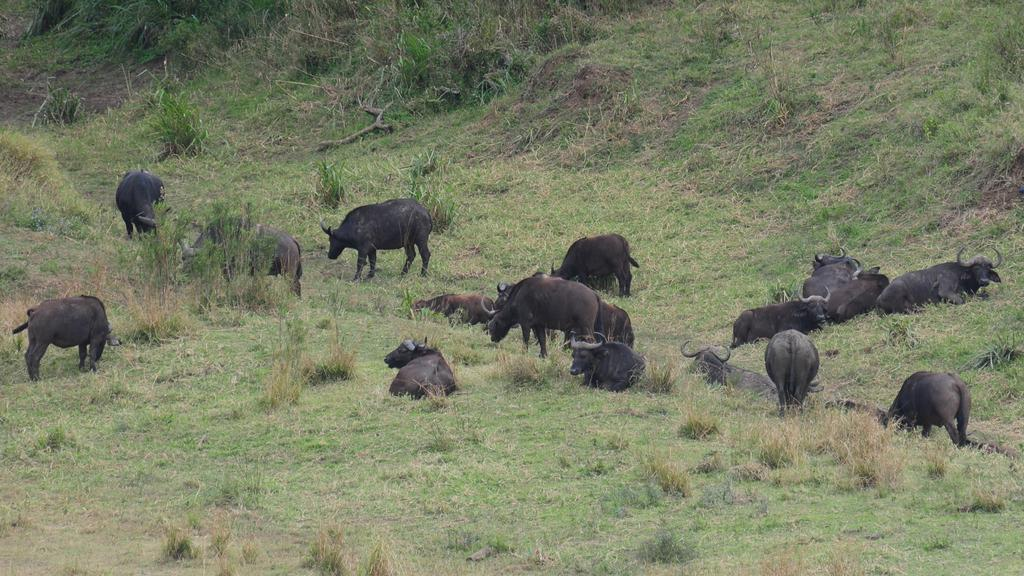What types of living organisms can be seen in the image? There are animals in the image. Where are the animals located? The animals are on a grassland. What shape is the drain in the image? There is no drain present in the image. How does love manifest itself in the image? The concept of love is not present in the image, as it features animals on a grassland. 